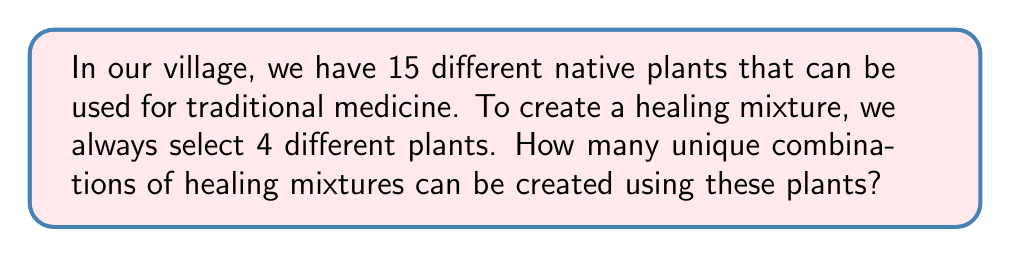Solve this math problem. Let's approach this step-by-step:

1) This is a combination problem. We are selecting 4 plants out of 15, where the order doesn't matter (it's the same mixture regardless of the order we add the plants), and we don't use the same plant more than once in a mixture.

2) The formula for combinations is:

   $$C(n,r) = \frac{n!}{r!(n-r)!}$$

   where $n$ is the total number of items to choose from, and $r$ is the number of items being chosen.

3) In this case, $n = 15$ (total number of plants) and $r = 4$ (number of plants in each mixture).

4) Plugging these numbers into our formula:

   $$C(15,4) = \frac{15!}{4!(15-4)!} = \frac{15!}{4!11!}$$

5) Expanding this:
   
   $$\frac{15 \times 14 \times 13 \times 12 \times 11!}{(4 \times 3 \times 2 \times 1) \times 11!}$$

6) The 11! cancels out in the numerator and denominator:

   $$\frac{15 \times 14 \times 13 \times 12}{4 \times 3 \times 2 \times 1} = \frac{32,760}{24} = 1,365$$

Therefore, there are 1,365 unique combinations of healing mixtures that can be created.
Answer: 1,365 